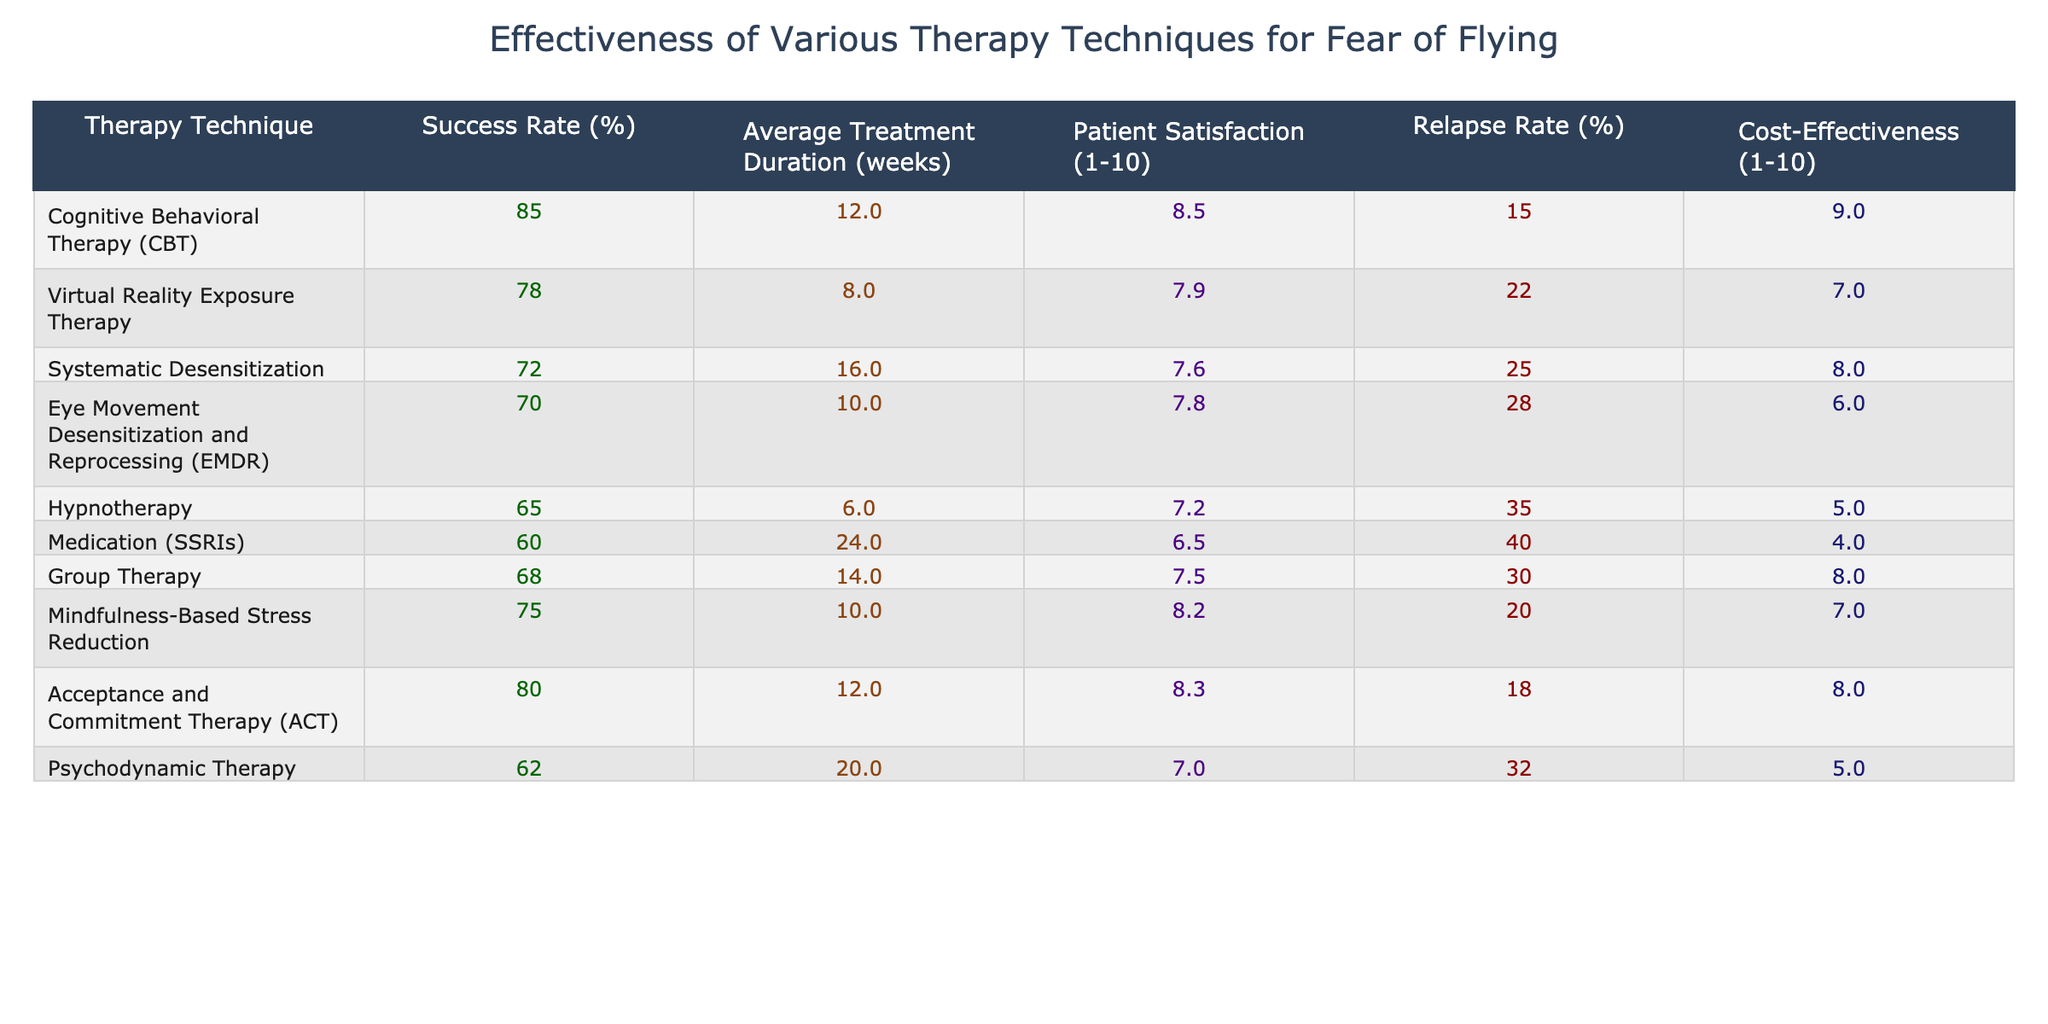What is the success rate of Cognitive Behavioral Therapy (CBT)? The table lists the success rate of CBT as 85%.
Answer: 85% Which therapy technique has the highest patient satisfaction rating? By reviewing the Patient Satisfaction column, CBT has the highest score of 8.5.
Answer: CBT What is the average treatment duration for Systematic Desensitization? The table shows that the average treatment duration for Systematic Desensitization is 16 weeks.
Answer: 16 weeks What is the relapse rate for Hypnotherapy? According to the table, the relapse rate for Hypnotherapy is 35%.
Answer: 35% Which therapy technique has a success rate below 70%? The techniques with a success rate below 70% are EMDR (70%), Hypnotherapy (65%), and Medication (SSRIs) (60%).
Answer: EMDR, Hypnotherapy, Medication (SSRIs) What is the average patient satisfaction across all therapy techniques? To find the average, we add all patient satisfaction ratings (8.5, 7.9, 7.6, 7.8, 7.2, 6.5, 7.5, 8.2, 8.3, 7.0) for a total of 78.5. Dividing by 10 gives an average of 7.85.
Answer: 7.85 Is Acceptance and Commitment Therapy (ACT) more cost-effective than Hypnotherapy? The table shows ACT with a cost-effectiveness rating of 8 and Hypnotherapy with a rating of 5, indicating ACT is more cost-effective.
Answer: Yes What is the difference in success rates between CBT and Medication (SSRIs)? The success rate of CBT is 85% while that of Medication (SSRIs) is 60%. The difference is 85 - 60 = 25%.
Answer: 25% Which therapy technique requires the longest average treatment duration? Reviewing the treatment durations, Medication (SSRIs) requires the longest average treatment duration of 24 weeks.
Answer: 24 weeks Is the relapse rate for Virtual Reality Exposure Therapy higher than that of Mindfulness-Based Stress Reduction? The relapse rate for Virtual Reality Exposure Therapy is 22%, while it's 20% for Mindfulness-Based Stress Reduction; hence, VR therapy has a higher rate.
Answer: Yes What is the most cost-effective therapy technique? The table indicates that CBT has the highest cost-effectiveness rating of 9, making it the most cost-effective therapy.
Answer: CBT 